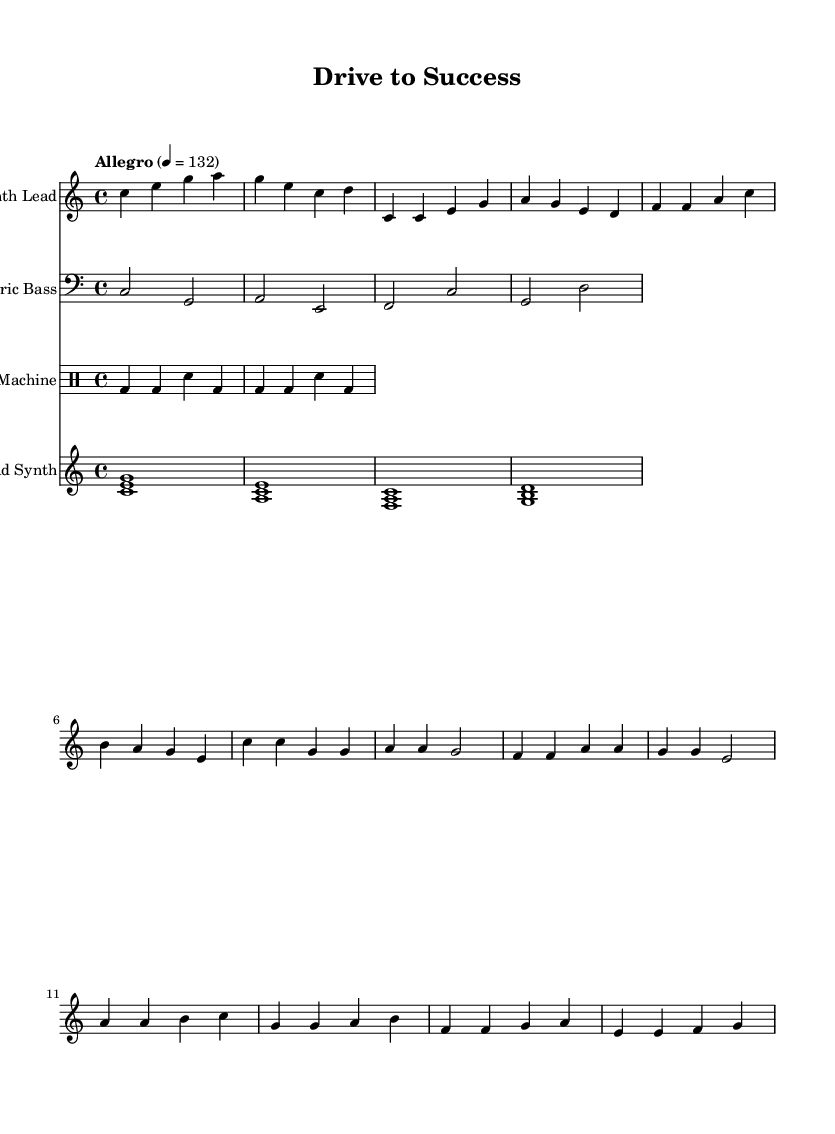What is the key signature of this music? The key signature is indicated at the beginning of the piece. In this case, it shows C major, which has no sharps or flats.
Answer: C major What is the time signature of this music? The time signature is displayed near the beginning; it shows 4/4, meaning there are four beats per measure and the quarter note gets one beat.
Answer: 4/4 What is the tempo indication of this music? The tempo is provided at the start with the marking "Allegro" and a metronome marking of 132, indicating a lively tempo.
Answer: Allegro 4 = 132 Identify the instrument for the second staff. The second staff is labeled with the name "Electric Bass," indicating that this part is intended for the electric bass instrument.
Answer: Electric Bass How many measures are in the chorus section? To find the number of measures in the chorus, we need to look closely at the notation in that section. Counting the measures gives a total of four.
Answer: 4 What chord does the pad synth sustain at the beginning? The pad synth part starts with the notes designated as <c e g>, which forms a C major chord.
Answer: C major Explain the role of the drum machine in this piece. The drum machine provides a rhythmic foundation throughout the composition. The repeated pattern helps maintain a steady beat, characteristic of upbeat electronic music.
Answer: Provides rhythm 